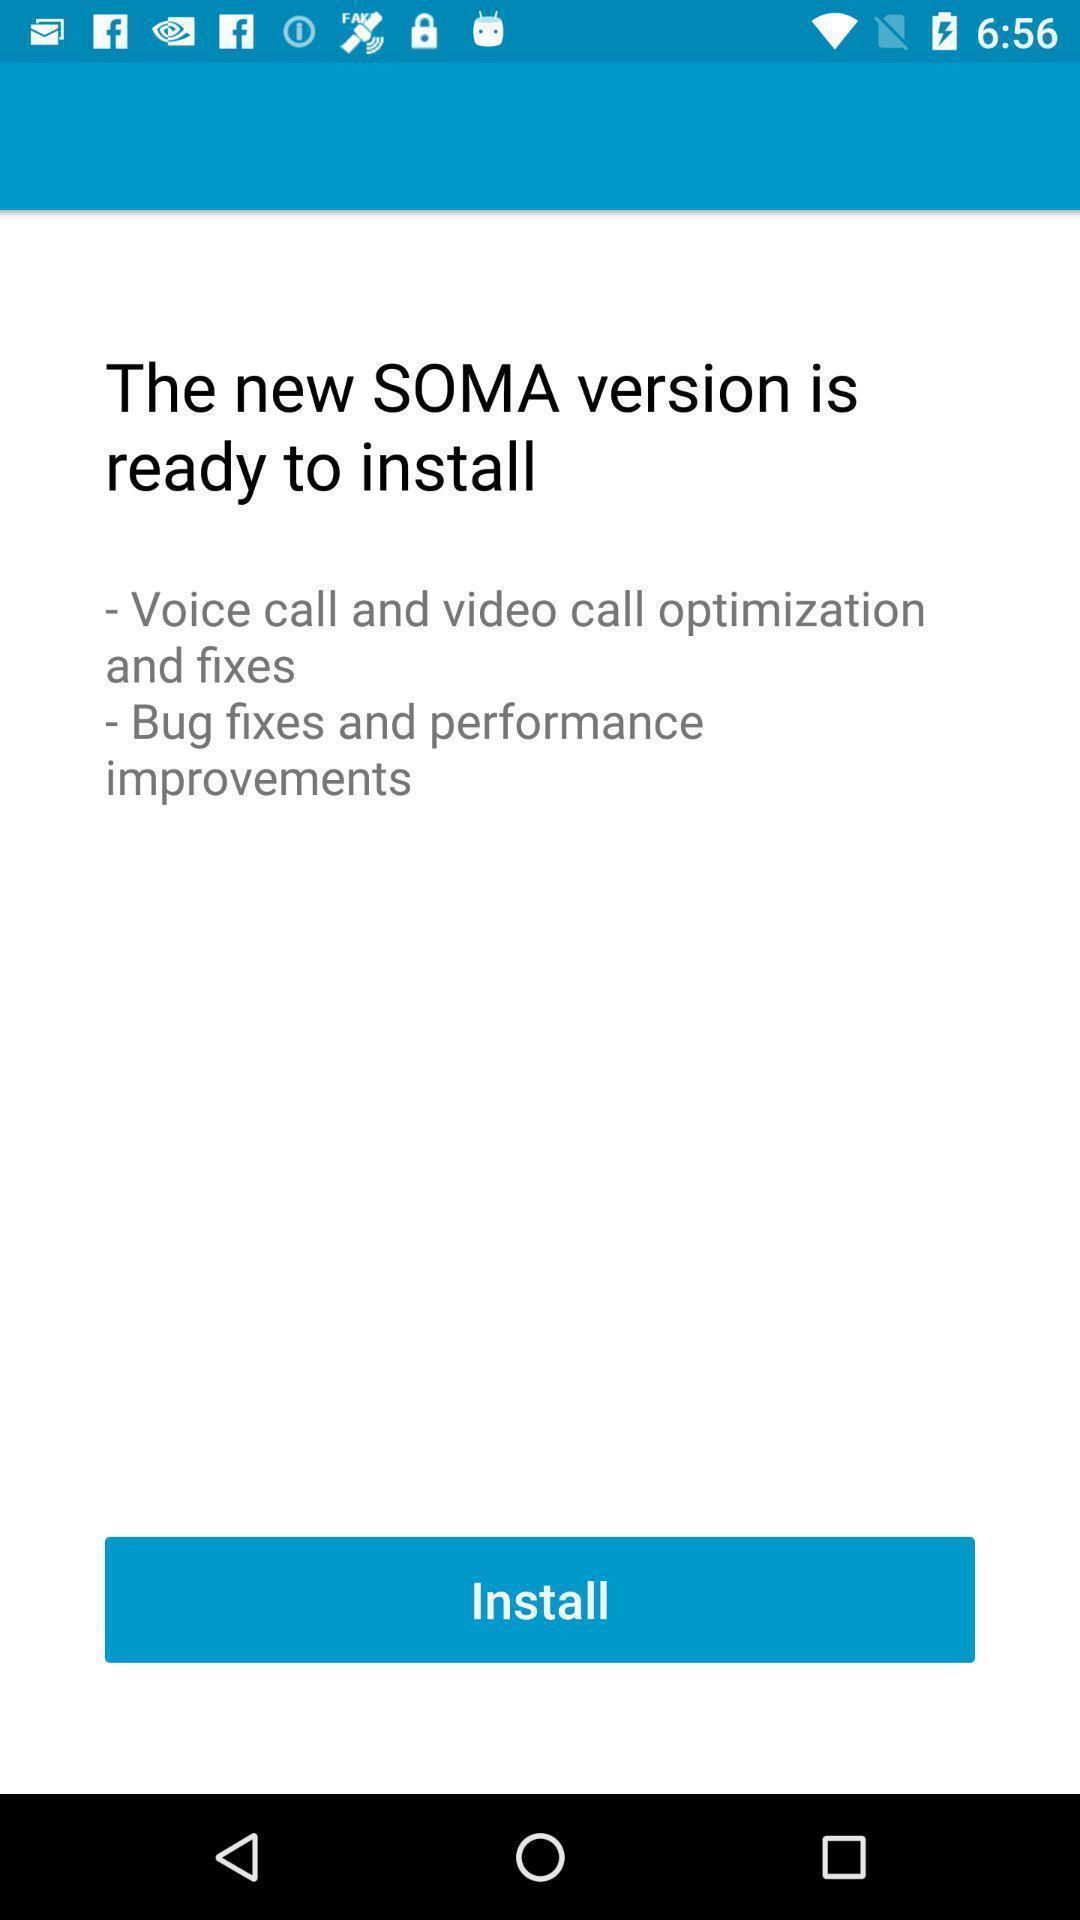Tell me about the visual elements in this screen capture. Screen shows to install a new version. 